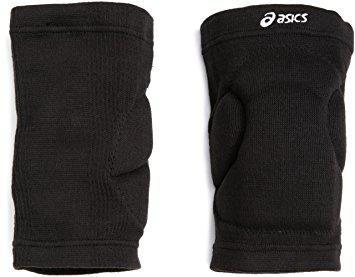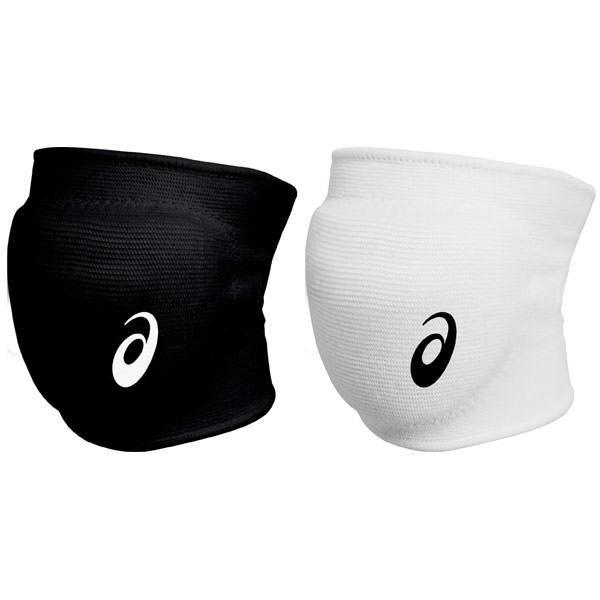The first image is the image on the left, the second image is the image on the right. For the images shown, is this caption "One image shows a black knee pad with a white logo and like a white knee pad with a black logo." true? Answer yes or no. Yes. 